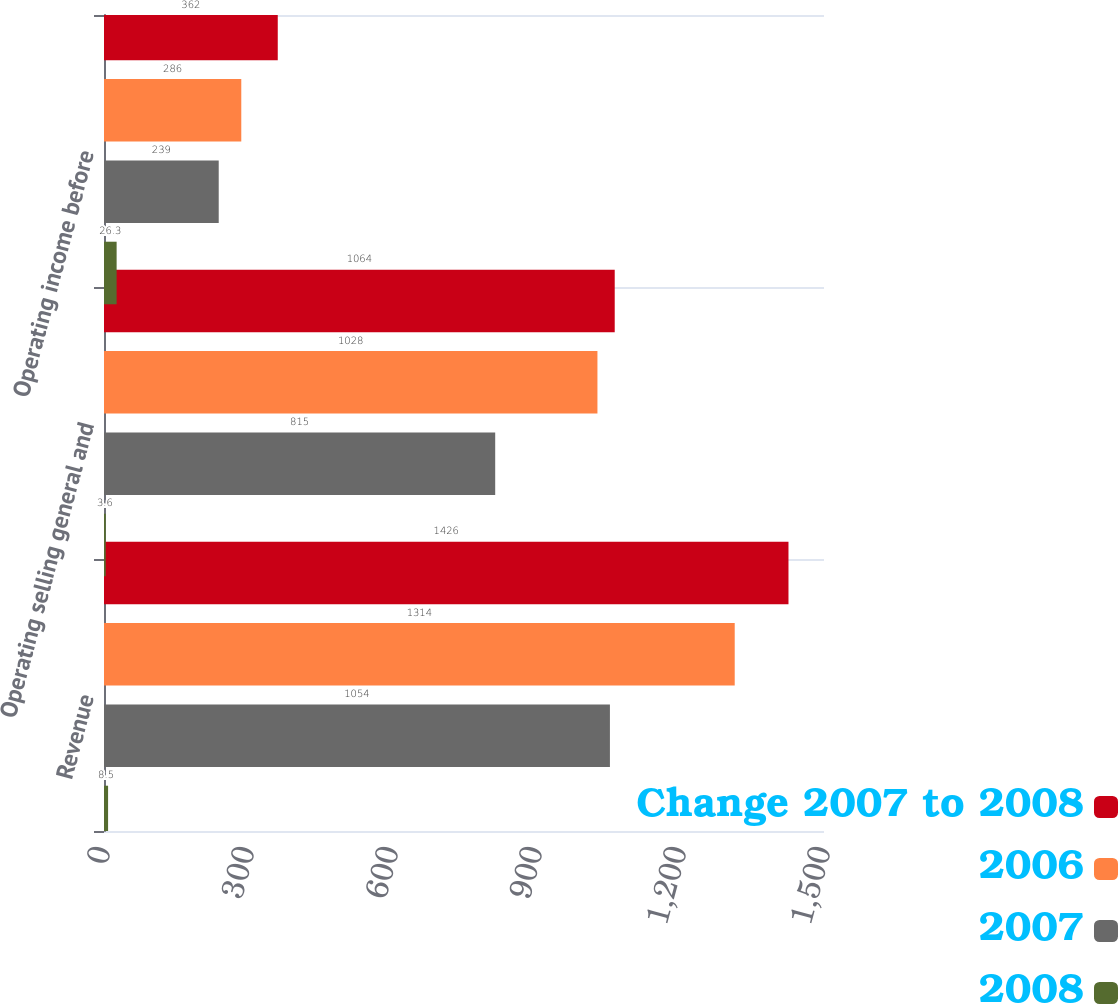Convert chart to OTSL. <chart><loc_0><loc_0><loc_500><loc_500><stacked_bar_chart><ecel><fcel>Revenue<fcel>Operating selling general and<fcel>Operating income before<nl><fcel>Change 2007 to 2008<fcel>1426<fcel>1064<fcel>362<nl><fcel>2006<fcel>1314<fcel>1028<fcel>286<nl><fcel>2007<fcel>1054<fcel>815<fcel>239<nl><fcel>2008<fcel>8.5<fcel>3.6<fcel>26.3<nl></chart> 